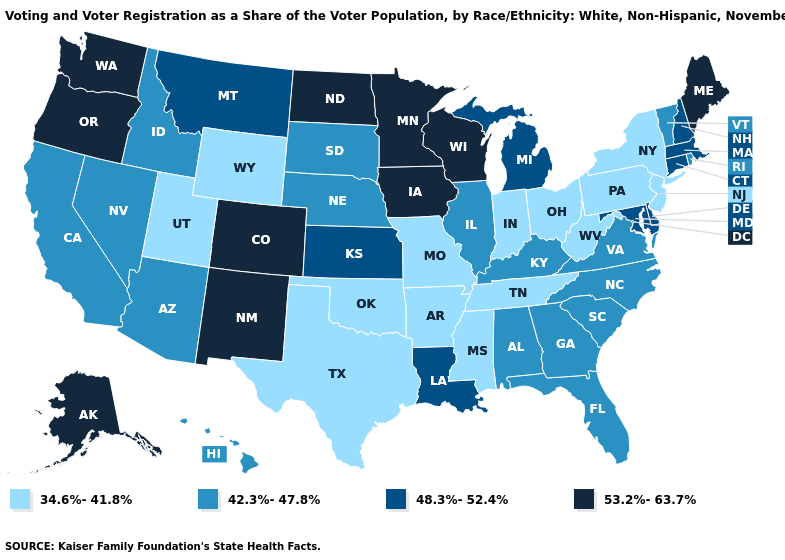What is the value of New York?
Give a very brief answer. 34.6%-41.8%. What is the value of Virginia?
Short answer required. 42.3%-47.8%. Among the states that border Montana , does North Dakota have the highest value?
Write a very short answer. Yes. Among the states that border Idaho , which have the lowest value?
Answer briefly. Utah, Wyoming. Does Indiana have the lowest value in the MidWest?
Concise answer only. Yes. What is the value of North Carolina?
Quick response, please. 42.3%-47.8%. What is the highest value in states that border Montana?
Answer briefly. 53.2%-63.7%. Which states hav the highest value in the MidWest?
Quick response, please. Iowa, Minnesota, North Dakota, Wisconsin. Name the states that have a value in the range 48.3%-52.4%?
Give a very brief answer. Connecticut, Delaware, Kansas, Louisiana, Maryland, Massachusetts, Michigan, Montana, New Hampshire. What is the lowest value in the Northeast?
Keep it brief. 34.6%-41.8%. Does Nebraska have a higher value than Florida?
Answer briefly. No. What is the lowest value in the USA?
Write a very short answer. 34.6%-41.8%. What is the highest value in states that border New Mexico?
Be succinct. 53.2%-63.7%. Which states have the lowest value in the USA?
Give a very brief answer. Arkansas, Indiana, Mississippi, Missouri, New Jersey, New York, Ohio, Oklahoma, Pennsylvania, Tennessee, Texas, Utah, West Virginia, Wyoming. 